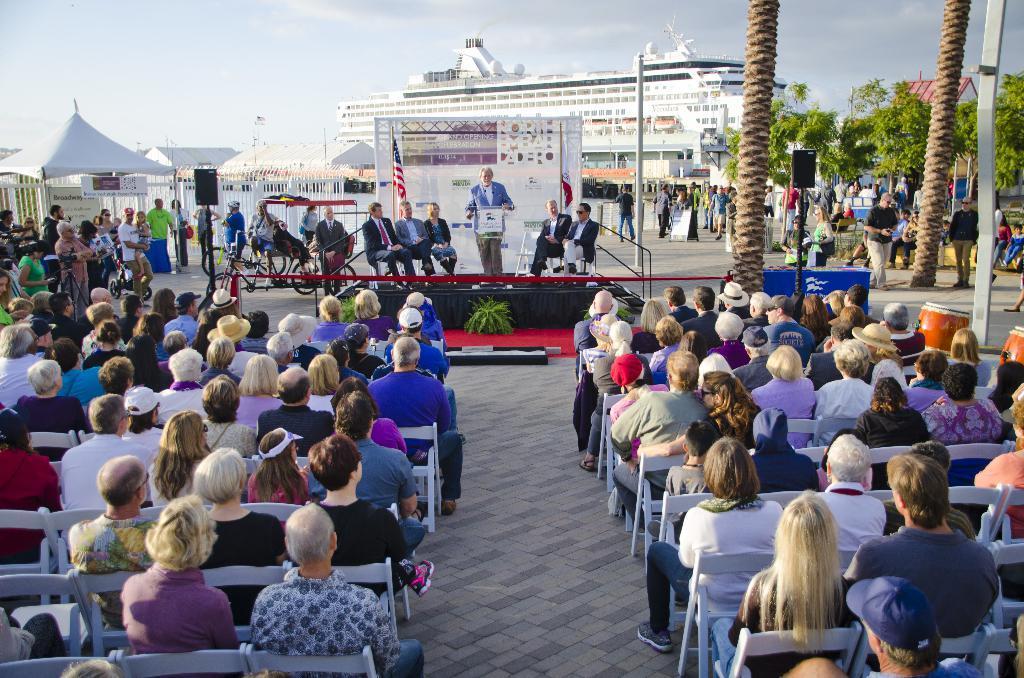Please provide a concise description of this image. In the foreground of the image we can see crowd sitting on the chairs. In the middle of the image we can see the tents, a stage on which some people are sitting and one person is standing and saying something. At the top of the image we can see a big ship and the sky. 